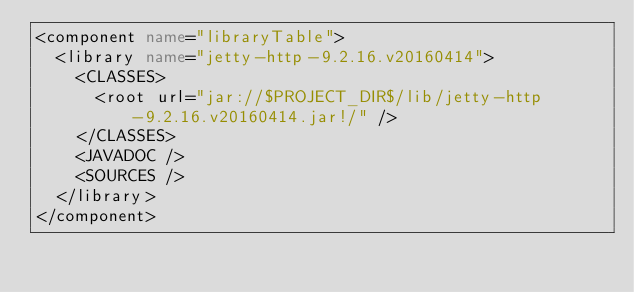<code> <loc_0><loc_0><loc_500><loc_500><_XML_><component name="libraryTable">
  <library name="jetty-http-9.2.16.v20160414">
    <CLASSES>
      <root url="jar://$PROJECT_DIR$/lib/jetty-http-9.2.16.v20160414.jar!/" />
    </CLASSES>
    <JAVADOC />
    <SOURCES />
  </library>
</component></code> 